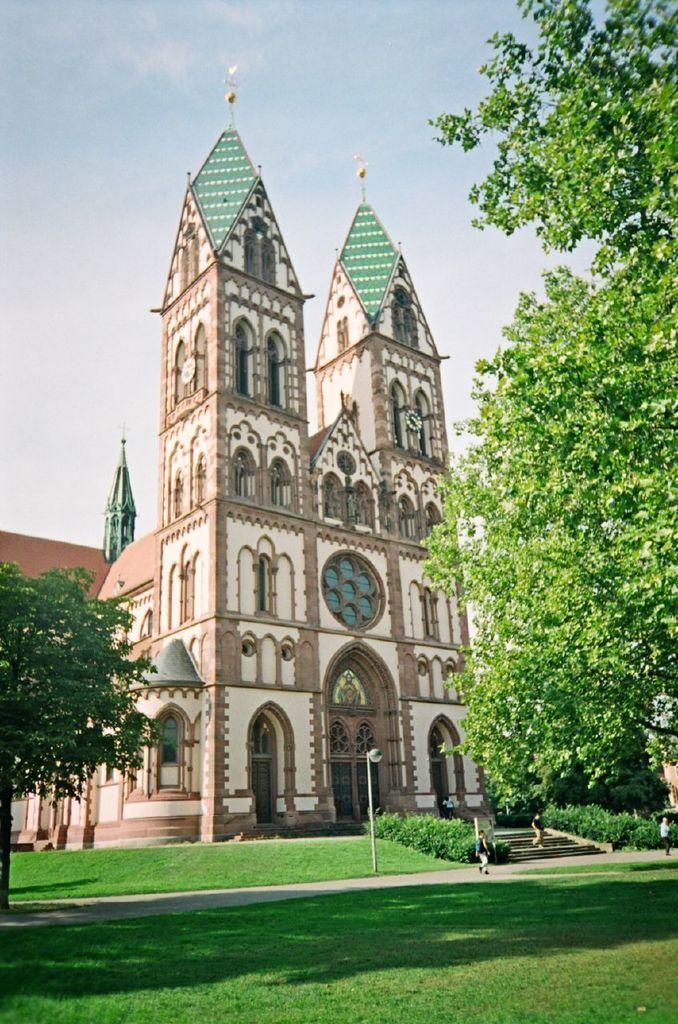Could you give a brief overview of what you see in this image? In this image there is a building, in front of the building there are stairs, on the stairs and on the road there are some people. In front of the building there are trees and grass on the surface. At the top of the image there are clouds in the sky. 